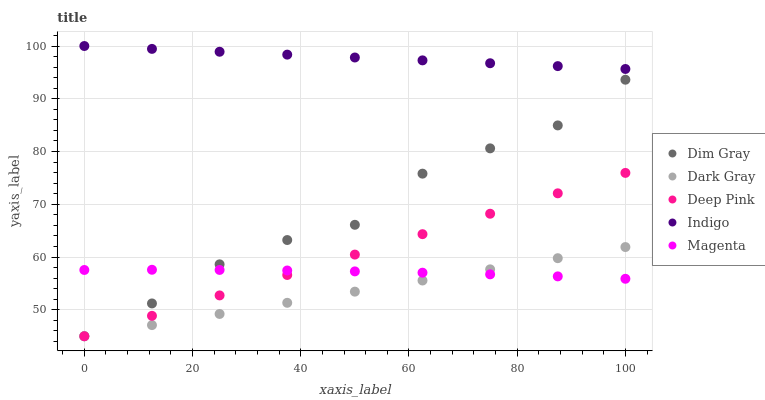Does Dark Gray have the minimum area under the curve?
Answer yes or no. Yes. Does Indigo have the maximum area under the curve?
Answer yes or no. Yes. Does Magenta have the minimum area under the curve?
Answer yes or no. No. Does Magenta have the maximum area under the curve?
Answer yes or no. No. Is Dark Gray the smoothest?
Answer yes or no. Yes. Is Dim Gray the roughest?
Answer yes or no. Yes. Is Magenta the smoothest?
Answer yes or no. No. Is Magenta the roughest?
Answer yes or no. No. Does Dark Gray have the lowest value?
Answer yes or no. Yes. Does Magenta have the lowest value?
Answer yes or no. No. Does Indigo have the highest value?
Answer yes or no. Yes. Does Dim Gray have the highest value?
Answer yes or no. No. Is Deep Pink less than Indigo?
Answer yes or no. Yes. Is Indigo greater than Magenta?
Answer yes or no. Yes. Does Dark Gray intersect Deep Pink?
Answer yes or no. Yes. Is Dark Gray less than Deep Pink?
Answer yes or no. No. Is Dark Gray greater than Deep Pink?
Answer yes or no. No. Does Deep Pink intersect Indigo?
Answer yes or no. No. 